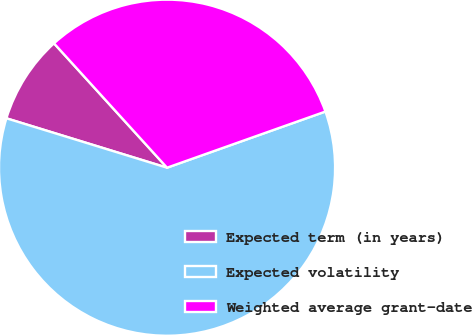Convert chart. <chart><loc_0><loc_0><loc_500><loc_500><pie_chart><fcel>Expected term (in years)<fcel>Expected volatility<fcel>Weighted average grant-date<nl><fcel>8.51%<fcel>60.17%<fcel>31.32%<nl></chart> 